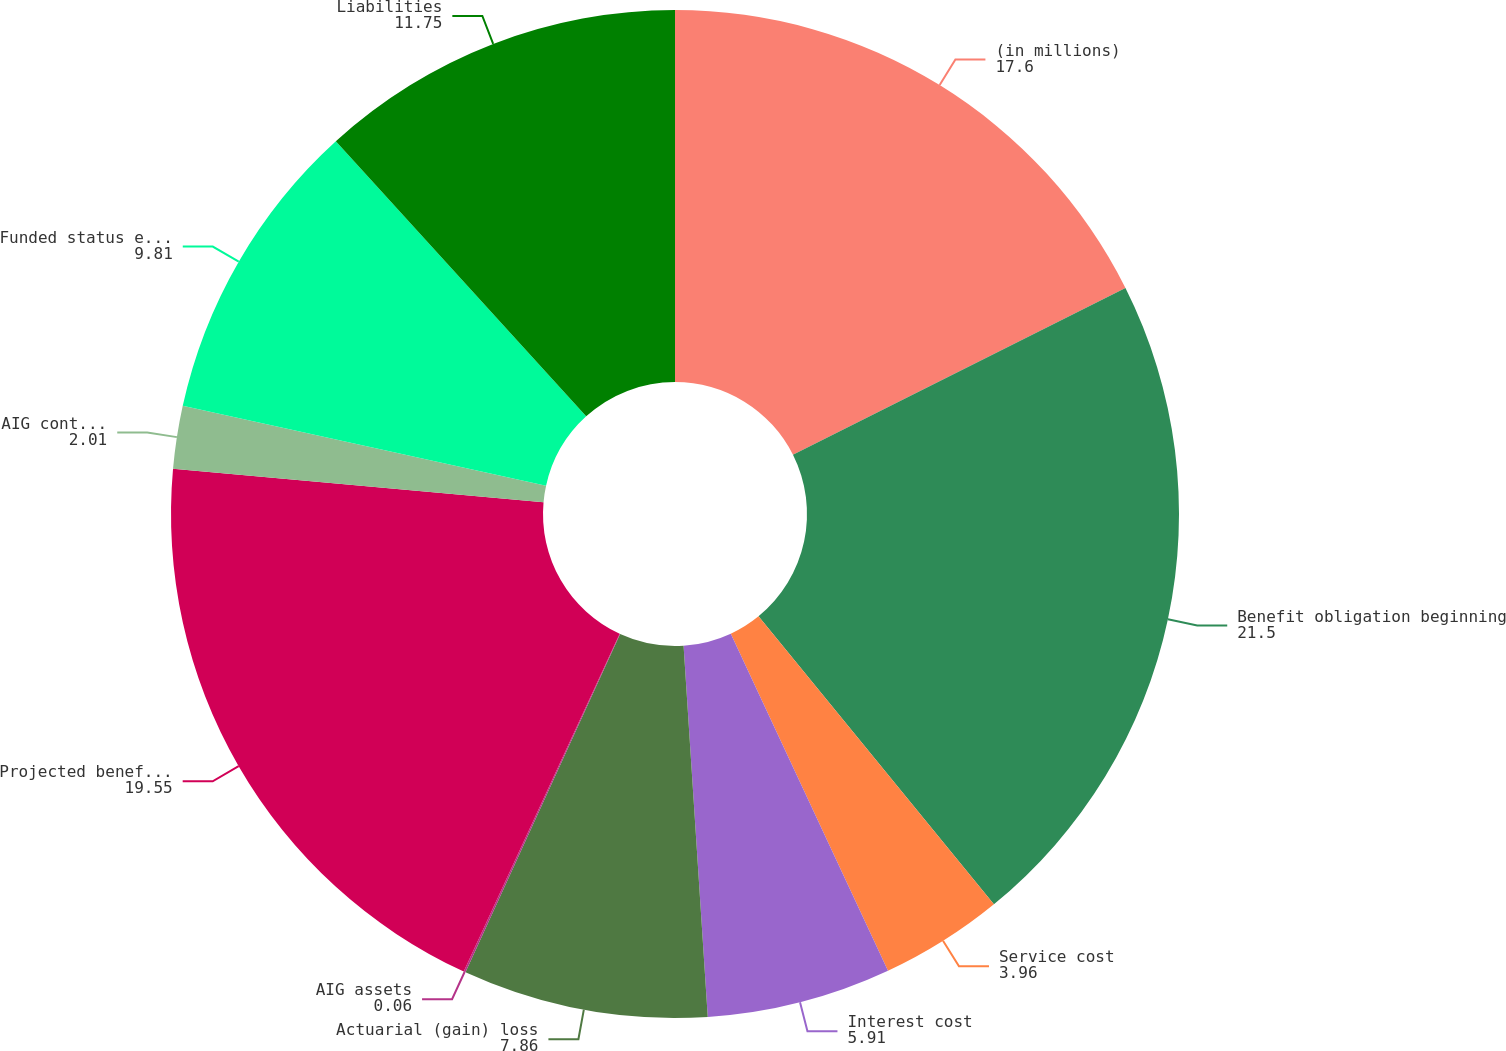Convert chart to OTSL. <chart><loc_0><loc_0><loc_500><loc_500><pie_chart><fcel>(in millions)<fcel>Benefit obligation beginning<fcel>Service cost<fcel>Interest cost<fcel>Actuarial (gain) loss<fcel>AIG assets<fcel>Projected benefit obligation<fcel>AIG contributions<fcel>Funded status end of year<fcel>Liabilities<nl><fcel>17.6%<fcel>21.5%<fcel>3.96%<fcel>5.91%<fcel>7.86%<fcel>0.06%<fcel>19.55%<fcel>2.01%<fcel>9.81%<fcel>11.75%<nl></chart> 